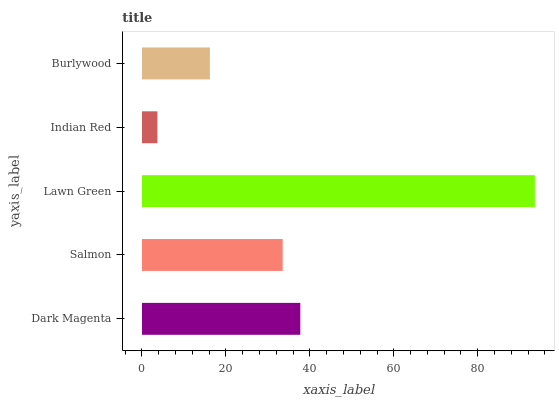Is Indian Red the minimum?
Answer yes or no. Yes. Is Lawn Green the maximum?
Answer yes or no. Yes. Is Salmon the minimum?
Answer yes or no. No. Is Salmon the maximum?
Answer yes or no. No. Is Dark Magenta greater than Salmon?
Answer yes or no. Yes. Is Salmon less than Dark Magenta?
Answer yes or no. Yes. Is Salmon greater than Dark Magenta?
Answer yes or no. No. Is Dark Magenta less than Salmon?
Answer yes or no. No. Is Salmon the high median?
Answer yes or no. Yes. Is Salmon the low median?
Answer yes or no. Yes. Is Dark Magenta the high median?
Answer yes or no. No. Is Indian Red the low median?
Answer yes or no. No. 